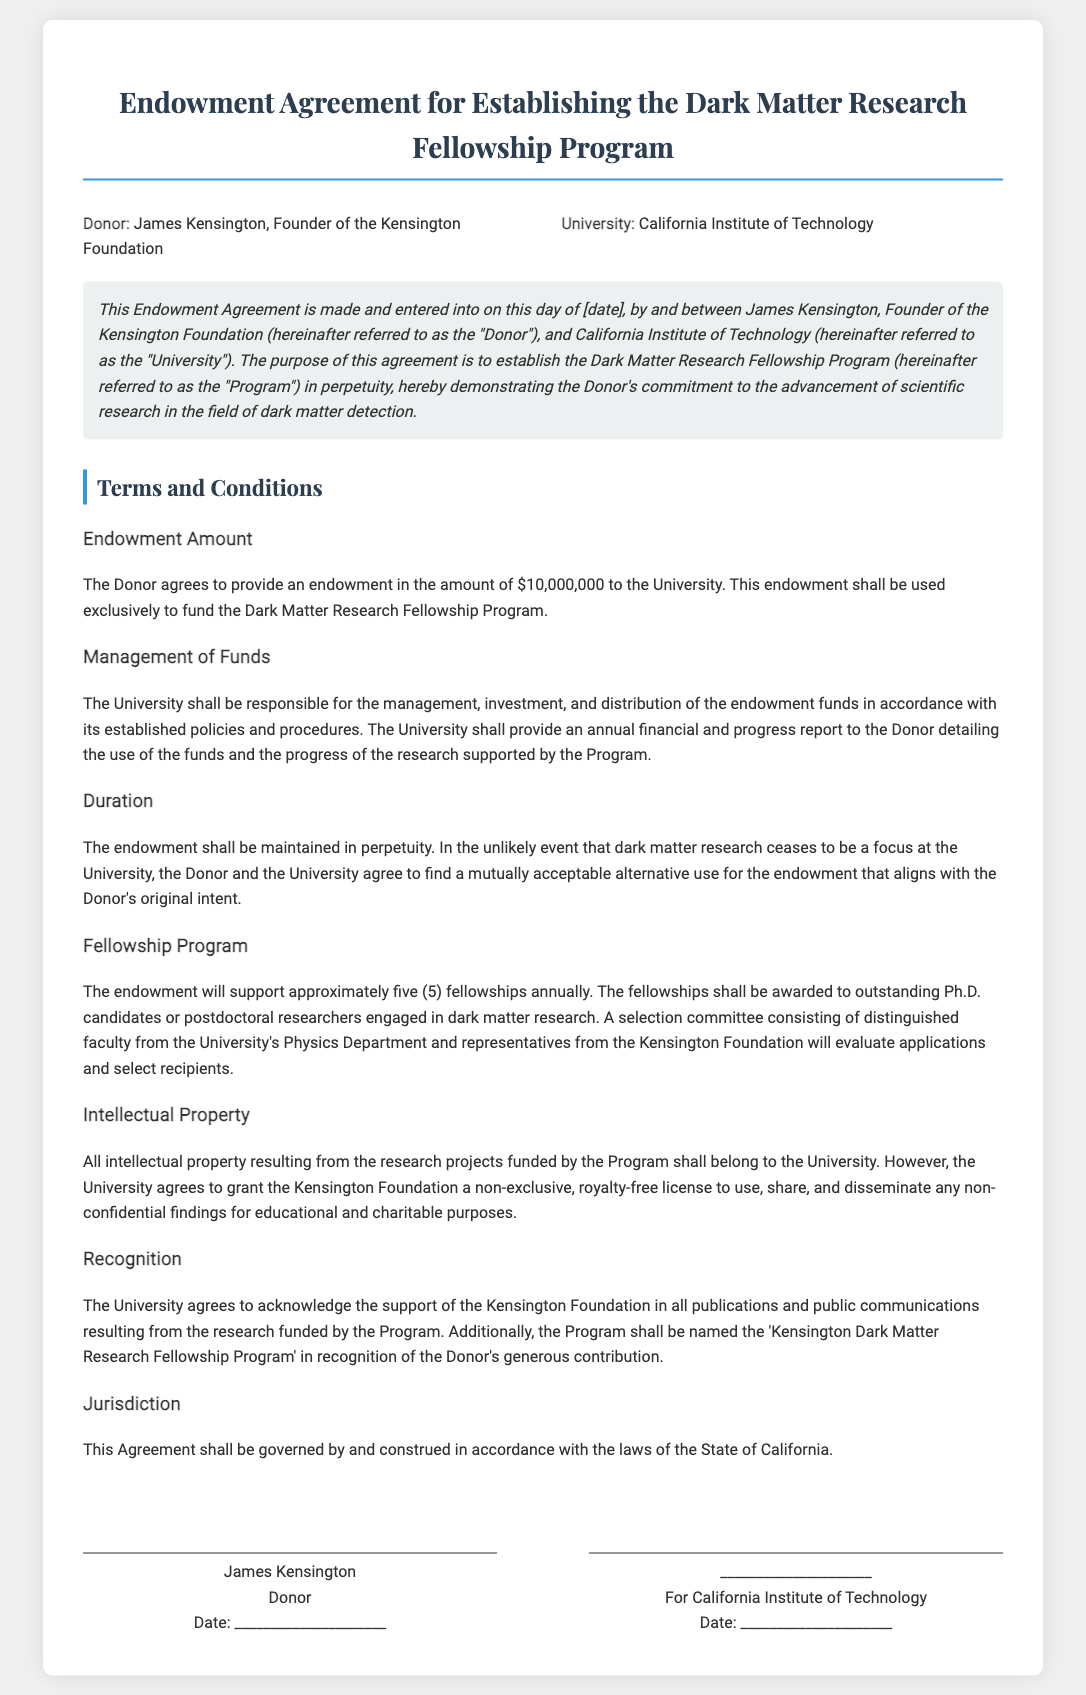What is the name of the donor? The donor is identified as James Kensington, Founder of the Kensington Foundation.
Answer: James Kensington How much is the endowment amount? The document specifies that the endowment amount provided by the donor is $10,000,000.
Answer: $10,000,000 How many fellowships will be supported annually? According to the document, the endowment will support approximately five fellowships annually for the Program.
Answer: five What is the name of the fellowship program? The document states that the program shall be named the 'Kensington Dark Matter Research Fellowship Program'.
Answer: Kensington Dark Matter Research Fellowship Program Who will manage the endowment funds? The management, investment, and distribution of the endowment funds will be the responsibility of the University.
Answer: University What happens if dark matter research ceases at the University? The document indicates that in such an event, the Donor and the University agree to find a mutually acceptable alternative use for the endowment.
Answer: mutually acceptable alternative use What type of license will the University grant the Kensington Foundation? The University agrees to grant a non-exclusive, royalty-free license to the Kensington Foundation for specific purposes.
Answer: non-exclusive, royalty-free license What is the jurisdiction for the agreement? The document clearly states that the Agreement shall be governed by the laws of the State of California.
Answer: State of California 